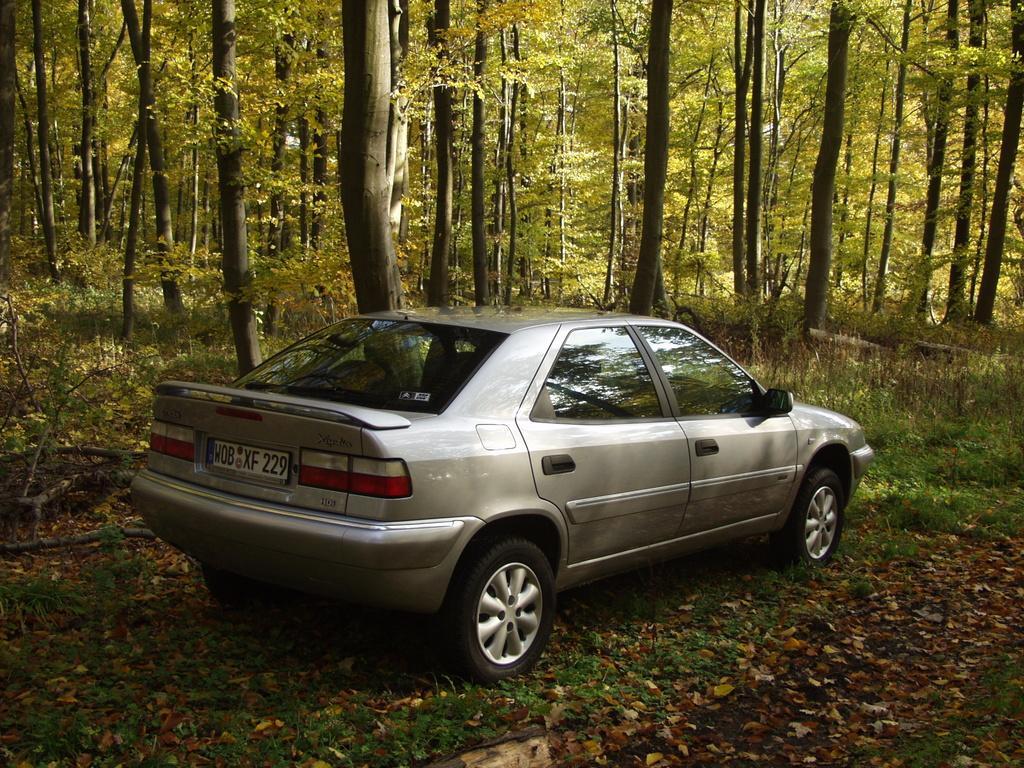Describe this image in one or two sentences. In this image there are vehicles, behind the vehicles there are trees. 